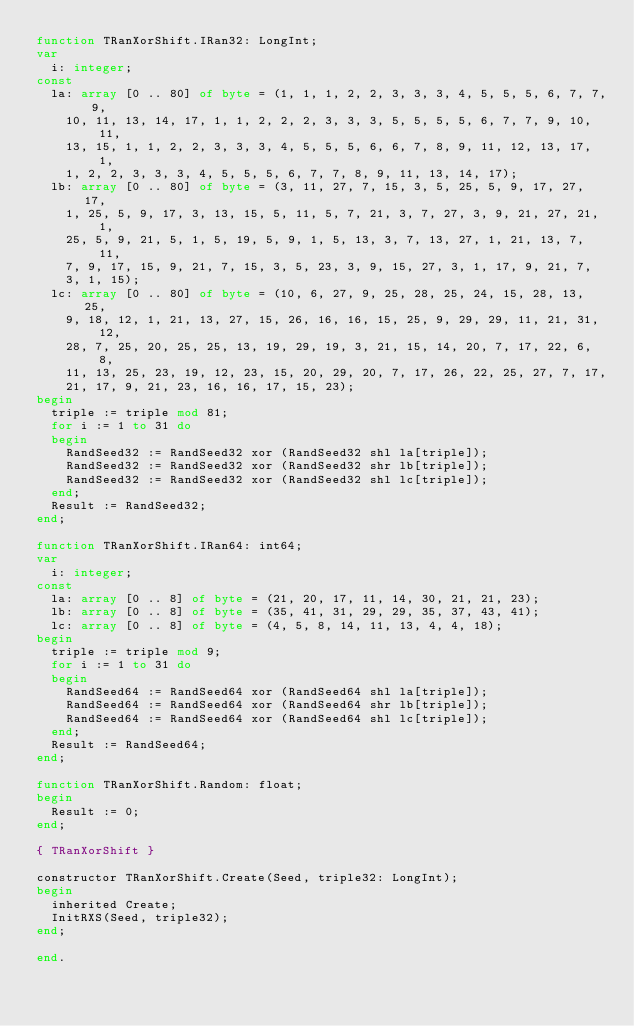Convert code to text. <code><loc_0><loc_0><loc_500><loc_500><_Pascal_>function TRanXorShift.IRan32: LongInt;
var
  i: integer;
const
  la: array [0 .. 80] of byte = (1, 1, 1, 2, 2, 3, 3, 3, 4, 5, 5, 5, 6, 7, 7, 9,
    10, 11, 13, 14, 17, 1, 1, 2, 2, 2, 3, 3, 3, 5, 5, 5, 5, 6, 7, 7, 9, 10, 11,
    13, 15, 1, 1, 2, 2, 3, 3, 3, 4, 5, 5, 5, 6, 6, 7, 8, 9, 11, 12, 13, 17, 1,
    1, 2, 2, 3, 3, 3, 4, 5, 5, 5, 6, 7, 7, 8, 9, 11, 13, 14, 17);
  lb: array [0 .. 80] of byte = (3, 11, 27, 7, 15, 3, 5, 25, 5, 9, 17, 27, 17,
    1, 25, 5, 9, 17, 3, 13, 15, 5, 11, 5, 7, 21, 3, 7, 27, 3, 9, 21, 27, 21, 1,
    25, 5, 9, 21, 5, 1, 5, 19, 5, 9, 1, 5, 13, 3, 7, 13, 27, 1, 21, 13, 7, 11,
    7, 9, 17, 15, 9, 21, 7, 15, 3, 5, 23, 3, 9, 15, 27, 3, 1, 17, 9, 21, 7,
    3, 1, 15);
  lc: array [0 .. 80] of byte = (10, 6, 27, 9, 25, 28, 25, 24, 15, 28, 13, 25,
    9, 18, 12, 1, 21, 13, 27, 15, 26, 16, 16, 15, 25, 9, 29, 29, 11, 21, 31, 12,
    28, 7, 25, 20, 25, 25, 13, 19, 29, 19, 3, 21, 15, 14, 20, 7, 17, 22, 6, 8,
    11, 13, 25, 23, 19, 12, 23, 15, 20, 29, 20, 7, 17, 26, 22, 25, 27, 7, 17,
    21, 17, 9, 21, 23, 16, 16, 17, 15, 23);
begin
  triple := triple mod 81;
  for i := 1 to 31 do
  begin
    RandSeed32 := RandSeed32 xor (RandSeed32 shl la[triple]);
    RandSeed32 := RandSeed32 xor (RandSeed32 shr lb[triple]);
    RandSeed32 := RandSeed32 xor (RandSeed32 shl lc[triple]);
  end;
  Result := RandSeed32;
end;

function TRanXorShift.IRan64: int64;
var
  i: integer;
const
  la: array [0 .. 8] of byte = (21, 20, 17, 11, 14, 30, 21, 21, 23);
  lb: array [0 .. 8] of byte = (35, 41, 31, 29, 29, 35, 37, 43, 41);
  lc: array [0 .. 8] of byte = (4, 5, 8, 14, 11, 13, 4, 4, 18);
begin
  triple := triple mod 9;
  for i := 1 to 31 do
  begin
    RandSeed64 := RandSeed64 xor (RandSeed64 shl la[triple]);
    RandSeed64 := RandSeed64 xor (RandSeed64 shr lb[triple]);
    RandSeed64 := RandSeed64 xor (RandSeed64 shl lc[triple]);
  end;
  Result := RandSeed64;
end;

function TRanXorShift.Random: float;
begin
  Result := 0;
end;

{ TRanXorShift }

constructor TRanXorShift.Create(Seed, triple32: LongInt);
begin
  inherited Create;
  InitRXS(Seed, triple32);
end;

end.
</code> 